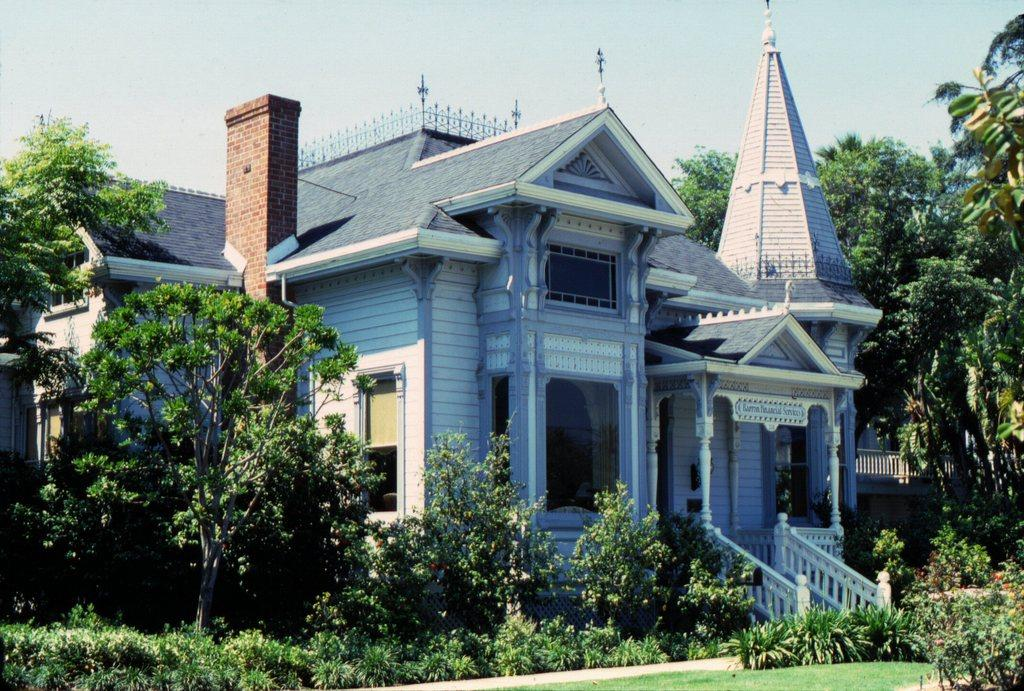What type of vegetation can be seen in the image? There are trees, plants, and grass in the image. What type of structure is present in the image? There is a house in the image. What feature of the house is mentioned in the facts? The house has windows. What part of the natural environment is visible in the image? The sky is visible in the background of the image. What type of silk is draped over the ornament in the image? There is no silk or ornament present in the image. How many baskets can be seen in the image? There are no baskets present in the image. 